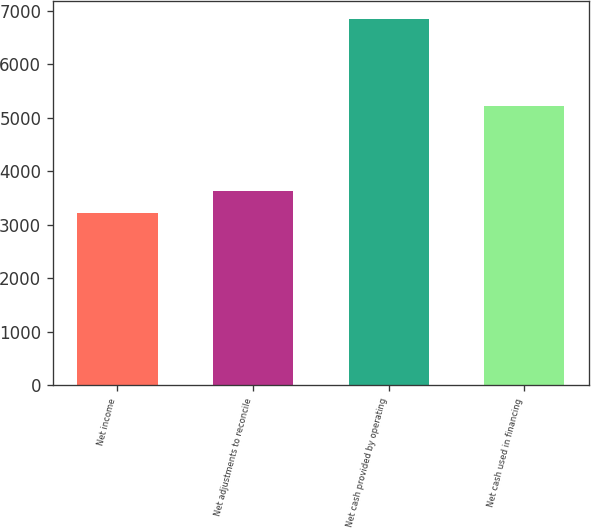Convert chart to OTSL. <chart><loc_0><loc_0><loc_500><loc_500><bar_chart><fcel>Net income<fcel>Net adjustments to reconcile<fcel>Net cash provided by operating<fcel>Net cash used in financing<nl><fcel>3216<fcel>3626<fcel>6842<fcel>5215<nl></chart> 